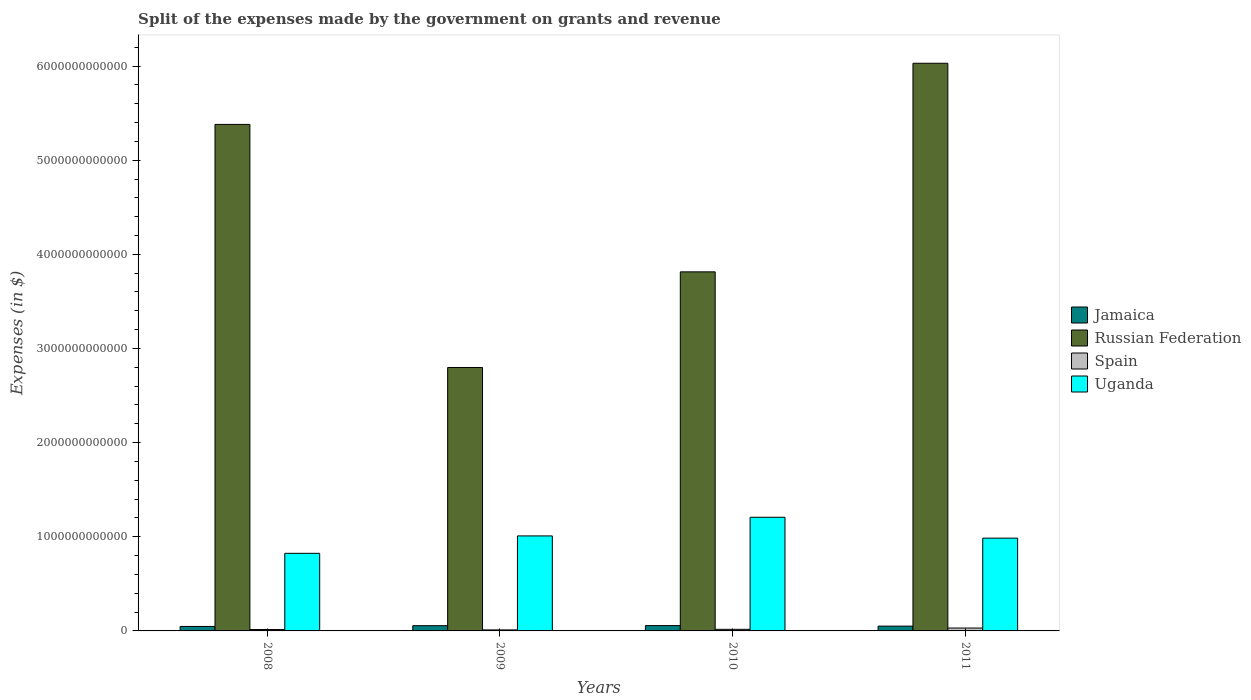How many groups of bars are there?
Your response must be concise. 4. Are the number of bars on each tick of the X-axis equal?
Your answer should be compact. Yes. How many bars are there on the 4th tick from the left?
Offer a very short reply. 4. How many bars are there on the 4th tick from the right?
Make the answer very short. 4. What is the expenses made by the government on grants and revenue in Spain in 2010?
Your response must be concise. 1.70e+1. Across all years, what is the maximum expenses made by the government on grants and revenue in Russian Federation?
Your answer should be very brief. 6.03e+12. Across all years, what is the minimum expenses made by the government on grants and revenue in Russian Federation?
Provide a succinct answer. 2.80e+12. In which year was the expenses made by the government on grants and revenue in Uganda minimum?
Offer a terse response. 2008. What is the total expenses made by the government on grants and revenue in Russian Federation in the graph?
Offer a terse response. 1.80e+13. What is the difference between the expenses made by the government on grants and revenue in Russian Federation in 2008 and that in 2010?
Offer a very short reply. 1.57e+12. What is the difference between the expenses made by the government on grants and revenue in Spain in 2008 and the expenses made by the government on grants and revenue in Jamaica in 2011?
Offer a terse response. -3.61e+1. What is the average expenses made by the government on grants and revenue in Jamaica per year?
Offer a terse response. 5.27e+1. In the year 2009, what is the difference between the expenses made by the government on grants and revenue in Spain and expenses made by the government on grants and revenue in Russian Federation?
Give a very brief answer. -2.79e+12. What is the ratio of the expenses made by the government on grants and revenue in Uganda in 2009 to that in 2010?
Provide a short and direct response. 0.84. Is the difference between the expenses made by the government on grants and revenue in Spain in 2008 and 2009 greater than the difference between the expenses made by the government on grants and revenue in Russian Federation in 2008 and 2009?
Your answer should be compact. No. What is the difference between the highest and the second highest expenses made by the government on grants and revenue in Uganda?
Your answer should be compact. 1.98e+11. What is the difference between the highest and the lowest expenses made by the government on grants and revenue in Spain?
Offer a terse response. 2.00e+1. In how many years, is the expenses made by the government on grants and revenue in Jamaica greater than the average expenses made by the government on grants and revenue in Jamaica taken over all years?
Give a very brief answer. 2. Is it the case that in every year, the sum of the expenses made by the government on grants and revenue in Uganda and expenses made by the government on grants and revenue in Russian Federation is greater than the sum of expenses made by the government on grants and revenue in Jamaica and expenses made by the government on grants and revenue in Spain?
Give a very brief answer. No. What does the 1st bar from the left in 2008 represents?
Your answer should be compact. Jamaica. What does the 1st bar from the right in 2009 represents?
Offer a very short reply. Uganda. How many bars are there?
Provide a succinct answer. 16. What is the difference between two consecutive major ticks on the Y-axis?
Your answer should be compact. 1.00e+12. Does the graph contain any zero values?
Offer a very short reply. No. Does the graph contain grids?
Keep it short and to the point. No. How many legend labels are there?
Your answer should be compact. 4. What is the title of the graph?
Give a very brief answer. Split of the expenses made by the government on grants and revenue. What is the label or title of the Y-axis?
Ensure brevity in your answer.  Expenses (in $). What is the Expenses (in $) in Jamaica in 2008?
Offer a very short reply. 4.75e+1. What is the Expenses (in $) of Russian Federation in 2008?
Give a very brief answer. 5.38e+12. What is the Expenses (in $) of Spain in 2008?
Ensure brevity in your answer.  1.49e+1. What is the Expenses (in $) of Uganda in 2008?
Provide a short and direct response. 8.24e+11. What is the Expenses (in $) in Jamaica in 2009?
Offer a very short reply. 5.55e+1. What is the Expenses (in $) in Russian Federation in 2009?
Offer a very short reply. 2.80e+12. What is the Expenses (in $) in Spain in 2009?
Keep it short and to the point. 1.08e+1. What is the Expenses (in $) of Uganda in 2009?
Ensure brevity in your answer.  1.01e+12. What is the Expenses (in $) in Jamaica in 2010?
Provide a short and direct response. 5.67e+1. What is the Expenses (in $) of Russian Federation in 2010?
Offer a very short reply. 3.81e+12. What is the Expenses (in $) in Spain in 2010?
Make the answer very short. 1.70e+1. What is the Expenses (in $) of Uganda in 2010?
Your response must be concise. 1.21e+12. What is the Expenses (in $) of Jamaica in 2011?
Provide a short and direct response. 5.10e+1. What is the Expenses (in $) in Russian Federation in 2011?
Ensure brevity in your answer.  6.03e+12. What is the Expenses (in $) in Spain in 2011?
Offer a very short reply. 3.08e+1. What is the Expenses (in $) in Uganda in 2011?
Give a very brief answer. 9.86e+11. Across all years, what is the maximum Expenses (in $) in Jamaica?
Provide a short and direct response. 5.67e+1. Across all years, what is the maximum Expenses (in $) in Russian Federation?
Ensure brevity in your answer.  6.03e+12. Across all years, what is the maximum Expenses (in $) in Spain?
Offer a very short reply. 3.08e+1. Across all years, what is the maximum Expenses (in $) of Uganda?
Give a very brief answer. 1.21e+12. Across all years, what is the minimum Expenses (in $) of Jamaica?
Make the answer very short. 4.75e+1. Across all years, what is the minimum Expenses (in $) in Russian Federation?
Give a very brief answer. 2.80e+12. Across all years, what is the minimum Expenses (in $) of Spain?
Your answer should be very brief. 1.08e+1. Across all years, what is the minimum Expenses (in $) of Uganda?
Provide a short and direct response. 8.24e+11. What is the total Expenses (in $) of Jamaica in the graph?
Your answer should be compact. 2.11e+11. What is the total Expenses (in $) of Russian Federation in the graph?
Make the answer very short. 1.80e+13. What is the total Expenses (in $) in Spain in the graph?
Offer a terse response. 7.35e+1. What is the total Expenses (in $) of Uganda in the graph?
Give a very brief answer. 4.03e+12. What is the difference between the Expenses (in $) of Jamaica in 2008 and that in 2009?
Your response must be concise. -8.07e+09. What is the difference between the Expenses (in $) of Russian Federation in 2008 and that in 2009?
Provide a short and direct response. 2.58e+12. What is the difference between the Expenses (in $) of Spain in 2008 and that in 2009?
Your answer should be very brief. 4.06e+09. What is the difference between the Expenses (in $) in Uganda in 2008 and that in 2009?
Give a very brief answer. -1.85e+11. What is the difference between the Expenses (in $) of Jamaica in 2008 and that in 2010?
Your answer should be compact. -9.24e+09. What is the difference between the Expenses (in $) in Russian Federation in 2008 and that in 2010?
Your response must be concise. 1.57e+12. What is the difference between the Expenses (in $) of Spain in 2008 and that in 2010?
Offer a terse response. -2.12e+09. What is the difference between the Expenses (in $) of Uganda in 2008 and that in 2010?
Provide a succinct answer. -3.83e+11. What is the difference between the Expenses (in $) in Jamaica in 2008 and that in 2011?
Your response must be concise. -3.50e+09. What is the difference between the Expenses (in $) in Russian Federation in 2008 and that in 2011?
Offer a very short reply. -6.49e+11. What is the difference between the Expenses (in $) in Spain in 2008 and that in 2011?
Your answer should be compact. -1.60e+1. What is the difference between the Expenses (in $) of Uganda in 2008 and that in 2011?
Provide a succinct answer. -1.61e+11. What is the difference between the Expenses (in $) in Jamaica in 2009 and that in 2010?
Your answer should be compact. -1.17e+09. What is the difference between the Expenses (in $) in Russian Federation in 2009 and that in 2010?
Keep it short and to the point. -1.02e+12. What is the difference between the Expenses (in $) of Spain in 2009 and that in 2010?
Ensure brevity in your answer.  -6.18e+09. What is the difference between the Expenses (in $) of Uganda in 2009 and that in 2010?
Your answer should be compact. -1.98e+11. What is the difference between the Expenses (in $) in Jamaica in 2009 and that in 2011?
Give a very brief answer. 4.57e+09. What is the difference between the Expenses (in $) in Russian Federation in 2009 and that in 2011?
Make the answer very short. -3.23e+12. What is the difference between the Expenses (in $) in Spain in 2009 and that in 2011?
Keep it short and to the point. -2.00e+1. What is the difference between the Expenses (in $) of Uganda in 2009 and that in 2011?
Offer a very short reply. 2.35e+1. What is the difference between the Expenses (in $) of Jamaica in 2010 and that in 2011?
Provide a short and direct response. 5.74e+09. What is the difference between the Expenses (in $) of Russian Federation in 2010 and that in 2011?
Ensure brevity in your answer.  -2.22e+12. What is the difference between the Expenses (in $) in Spain in 2010 and that in 2011?
Offer a terse response. -1.39e+1. What is the difference between the Expenses (in $) of Uganda in 2010 and that in 2011?
Keep it short and to the point. 2.22e+11. What is the difference between the Expenses (in $) of Jamaica in 2008 and the Expenses (in $) of Russian Federation in 2009?
Offer a terse response. -2.75e+12. What is the difference between the Expenses (in $) in Jamaica in 2008 and the Expenses (in $) in Spain in 2009?
Make the answer very short. 3.67e+1. What is the difference between the Expenses (in $) in Jamaica in 2008 and the Expenses (in $) in Uganda in 2009?
Provide a succinct answer. -9.62e+11. What is the difference between the Expenses (in $) of Russian Federation in 2008 and the Expenses (in $) of Spain in 2009?
Offer a very short reply. 5.37e+12. What is the difference between the Expenses (in $) in Russian Federation in 2008 and the Expenses (in $) in Uganda in 2009?
Your response must be concise. 4.37e+12. What is the difference between the Expenses (in $) of Spain in 2008 and the Expenses (in $) of Uganda in 2009?
Your answer should be compact. -9.94e+11. What is the difference between the Expenses (in $) of Jamaica in 2008 and the Expenses (in $) of Russian Federation in 2010?
Provide a short and direct response. -3.77e+12. What is the difference between the Expenses (in $) in Jamaica in 2008 and the Expenses (in $) in Spain in 2010?
Your answer should be very brief. 3.05e+1. What is the difference between the Expenses (in $) in Jamaica in 2008 and the Expenses (in $) in Uganda in 2010?
Your answer should be very brief. -1.16e+12. What is the difference between the Expenses (in $) in Russian Federation in 2008 and the Expenses (in $) in Spain in 2010?
Your response must be concise. 5.36e+12. What is the difference between the Expenses (in $) in Russian Federation in 2008 and the Expenses (in $) in Uganda in 2010?
Make the answer very short. 4.17e+12. What is the difference between the Expenses (in $) of Spain in 2008 and the Expenses (in $) of Uganda in 2010?
Offer a very short reply. -1.19e+12. What is the difference between the Expenses (in $) of Jamaica in 2008 and the Expenses (in $) of Russian Federation in 2011?
Your response must be concise. -5.98e+12. What is the difference between the Expenses (in $) in Jamaica in 2008 and the Expenses (in $) in Spain in 2011?
Give a very brief answer. 1.66e+1. What is the difference between the Expenses (in $) of Jamaica in 2008 and the Expenses (in $) of Uganda in 2011?
Offer a terse response. -9.38e+11. What is the difference between the Expenses (in $) of Russian Federation in 2008 and the Expenses (in $) of Spain in 2011?
Your response must be concise. 5.35e+12. What is the difference between the Expenses (in $) in Russian Federation in 2008 and the Expenses (in $) in Uganda in 2011?
Ensure brevity in your answer.  4.39e+12. What is the difference between the Expenses (in $) in Spain in 2008 and the Expenses (in $) in Uganda in 2011?
Your response must be concise. -9.71e+11. What is the difference between the Expenses (in $) in Jamaica in 2009 and the Expenses (in $) in Russian Federation in 2010?
Provide a succinct answer. -3.76e+12. What is the difference between the Expenses (in $) of Jamaica in 2009 and the Expenses (in $) of Spain in 2010?
Make the answer very short. 3.85e+1. What is the difference between the Expenses (in $) of Jamaica in 2009 and the Expenses (in $) of Uganda in 2010?
Your response must be concise. -1.15e+12. What is the difference between the Expenses (in $) in Russian Federation in 2009 and the Expenses (in $) in Spain in 2010?
Provide a succinct answer. 2.78e+12. What is the difference between the Expenses (in $) of Russian Federation in 2009 and the Expenses (in $) of Uganda in 2010?
Your response must be concise. 1.59e+12. What is the difference between the Expenses (in $) in Spain in 2009 and the Expenses (in $) in Uganda in 2010?
Give a very brief answer. -1.20e+12. What is the difference between the Expenses (in $) in Jamaica in 2009 and the Expenses (in $) in Russian Federation in 2011?
Your answer should be compact. -5.97e+12. What is the difference between the Expenses (in $) of Jamaica in 2009 and the Expenses (in $) of Spain in 2011?
Your answer should be compact. 2.47e+1. What is the difference between the Expenses (in $) of Jamaica in 2009 and the Expenses (in $) of Uganda in 2011?
Your answer should be compact. -9.30e+11. What is the difference between the Expenses (in $) of Russian Federation in 2009 and the Expenses (in $) of Spain in 2011?
Your answer should be very brief. 2.77e+12. What is the difference between the Expenses (in $) of Russian Federation in 2009 and the Expenses (in $) of Uganda in 2011?
Provide a succinct answer. 1.81e+12. What is the difference between the Expenses (in $) of Spain in 2009 and the Expenses (in $) of Uganda in 2011?
Keep it short and to the point. -9.75e+11. What is the difference between the Expenses (in $) in Jamaica in 2010 and the Expenses (in $) in Russian Federation in 2011?
Provide a succinct answer. -5.97e+12. What is the difference between the Expenses (in $) of Jamaica in 2010 and the Expenses (in $) of Spain in 2011?
Provide a succinct answer. 2.59e+1. What is the difference between the Expenses (in $) of Jamaica in 2010 and the Expenses (in $) of Uganda in 2011?
Give a very brief answer. -9.29e+11. What is the difference between the Expenses (in $) in Russian Federation in 2010 and the Expenses (in $) in Spain in 2011?
Your answer should be very brief. 3.78e+12. What is the difference between the Expenses (in $) in Russian Federation in 2010 and the Expenses (in $) in Uganda in 2011?
Your answer should be very brief. 2.83e+12. What is the difference between the Expenses (in $) in Spain in 2010 and the Expenses (in $) in Uganda in 2011?
Make the answer very short. -9.69e+11. What is the average Expenses (in $) of Jamaica per year?
Your response must be concise. 5.27e+1. What is the average Expenses (in $) of Russian Federation per year?
Offer a terse response. 4.51e+12. What is the average Expenses (in $) of Spain per year?
Provide a succinct answer. 1.84e+1. What is the average Expenses (in $) of Uganda per year?
Keep it short and to the point. 1.01e+12. In the year 2008, what is the difference between the Expenses (in $) in Jamaica and Expenses (in $) in Russian Federation?
Your answer should be very brief. -5.33e+12. In the year 2008, what is the difference between the Expenses (in $) in Jamaica and Expenses (in $) in Spain?
Your response must be concise. 3.26e+1. In the year 2008, what is the difference between the Expenses (in $) in Jamaica and Expenses (in $) in Uganda?
Your response must be concise. -7.77e+11. In the year 2008, what is the difference between the Expenses (in $) in Russian Federation and Expenses (in $) in Spain?
Ensure brevity in your answer.  5.37e+12. In the year 2008, what is the difference between the Expenses (in $) in Russian Federation and Expenses (in $) in Uganda?
Give a very brief answer. 4.56e+12. In the year 2008, what is the difference between the Expenses (in $) of Spain and Expenses (in $) of Uganda?
Make the answer very short. -8.09e+11. In the year 2009, what is the difference between the Expenses (in $) of Jamaica and Expenses (in $) of Russian Federation?
Your answer should be compact. -2.74e+12. In the year 2009, what is the difference between the Expenses (in $) in Jamaica and Expenses (in $) in Spain?
Provide a short and direct response. 4.47e+1. In the year 2009, what is the difference between the Expenses (in $) in Jamaica and Expenses (in $) in Uganda?
Offer a terse response. -9.54e+11. In the year 2009, what is the difference between the Expenses (in $) in Russian Federation and Expenses (in $) in Spain?
Your response must be concise. 2.79e+12. In the year 2009, what is the difference between the Expenses (in $) in Russian Federation and Expenses (in $) in Uganda?
Offer a terse response. 1.79e+12. In the year 2009, what is the difference between the Expenses (in $) of Spain and Expenses (in $) of Uganda?
Provide a succinct answer. -9.98e+11. In the year 2010, what is the difference between the Expenses (in $) of Jamaica and Expenses (in $) of Russian Federation?
Offer a terse response. -3.76e+12. In the year 2010, what is the difference between the Expenses (in $) of Jamaica and Expenses (in $) of Spain?
Make the answer very short. 3.97e+1. In the year 2010, what is the difference between the Expenses (in $) of Jamaica and Expenses (in $) of Uganda?
Your response must be concise. -1.15e+12. In the year 2010, what is the difference between the Expenses (in $) in Russian Federation and Expenses (in $) in Spain?
Ensure brevity in your answer.  3.80e+12. In the year 2010, what is the difference between the Expenses (in $) of Russian Federation and Expenses (in $) of Uganda?
Your response must be concise. 2.61e+12. In the year 2010, what is the difference between the Expenses (in $) in Spain and Expenses (in $) in Uganda?
Your response must be concise. -1.19e+12. In the year 2011, what is the difference between the Expenses (in $) in Jamaica and Expenses (in $) in Russian Federation?
Offer a very short reply. -5.98e+12. In the year 2011, what is the difference between the Expenses (in $) in Jamaica and Expenses (in $) in Spain?
Give a very brief answer. 2.01e+1. In the year 2011, what is the difference between the Expenses (in $) of Jamaica and Expenses (in $) of Uganda?
Ensure brevity in your answer.  -9.35e+11. In the year 2011, what is the difference between the Expenses (in $) of Russian Federation and Expenses (in $) of Spain?
Your answer should be very brief. 6.00e+12. In the year 2011, what is the difference between the Expenses (in $) in Russian Federation and Expenses (in $) in Uganda?
Offer a terse response. 5.04e+12. In the year 2011, what is the difference between the Expenses (in $) in Spain and Expenses (in $) in Uganda?
Offer a very short reply. -9.55e+11. What is the ratio of the Expenses (in $) in Jamaica in 2008 to that in 2009?
Ensure brevity in your answer.  0.85. What is the ratio of the Expenses (in $) of Russian Federation in 2008 to that in 2009?
Your answer should be very brief. 1.92. What is the ratio of the Expenses (in $) of Spain in 2008 to that in 2009?
Provide a short and direct response. 1.38. What is the ratio of the Expenses (in $) of Uganda in 2008 to that in 2009?
Give a very brief answer. 0.82. What is the ratio of the Expenses (in $) in Jamaica in 2008 to that in 2010?
Your response must be concise. 0.84. What is the ratio of the Expenses (in $) in Russian Federation in 2008 to that in 2010?
Keep it short and to the point. 1.41. What is the ratio of the Expenses (in $) of Spain in 2008 to that in 2010?
Give a very brief answer. 0.87. What is the ratio of the Expenses (in $) of Uganda in 2008 to that in 2010?
Provide a succinct answer. 0.68. What is the ratio of the Expenses (in $) of Jamaica in 2008 to that in 2011?
Make the answer very short. 0.93. What is the ratio of the Expenses (in $) in Russian Federation in 2008 to that in 2011?
Offer a very short reply. 0.89. What is the ratio of the Expenses (in $) in Spain in 2008 to that in 2011?
Your response must be concise. 0.48. What is the ratio of the Expenses (in $) of Uganda in 2008 to that in 2011?
Provide a short and direct response. 0.84. What is the ratio of the Expenses (in $) of Jamaica in 2009 to that in 2010?
Keep it short and to the point. 0.98. What is the ratio of the Expenses (in $) in Russian Federation in 2009 to that in 2010?
Make the answer very short. 0.73. What is the ratio of the Expenses (in $) in Spain in 2009 to that in 2010?
Offer a terse response. 0.64. What is the ratio of the Expenses (in $) of Uganda in 2009 to that in 2010?
Your answer should be very brief. 0.84. What is the ratio of the Expenses (in $) of Jamaica in 2009 to that in 2011?
Your answer should be very brief. 1.09. What is the ratio of the Expenses (in $) of Russian Federation in 2009 to that in 2011?
Your answer should be very brief. 0.46. What is the ratio of the Expenses (in $) in Spain in 2009 to that in 2011?
Offer a very short reply. 0.35. What is the ratio of the Expenses (in $) of Uganda in 2009 to that in 2011?
Give a very brief answer. 1.02. What is the ratio of the Expenses (in $) of Jamaica in 2010 to that in 2011?
Your answer should be compact. 1.11. What is the ratio of the Expenses (in $) in Russian Federation in 2010 to that in 2011?
Offer a terse response. 0.63. What is the ratio of the Expenses (in $) in Spain in 2010 to that in 2011?
Your response must be concise. 0.55. What is the ratio of the Expenses (in $) of Uganda in 2010 to that in 2011?
Your answer should be compact. 1.22. What is the difference between the highest and the second highest Expenses (in $) of Jamaica?
Your answer should be compact. 1.17e+09. What is the difference between the highest and the second highest Expenses (in $) in Russian Federation?
Offer a very short reply. 6.49e+11. What is the difference between the highest and the second highest Expenses (in $) of Spain?
Offer a very short reply. 1.39e+1. What is the difference between the highest and the second highest Expenses (in $) of Uganda?
Provide a succinct answer. 1.98e+11. What is the difference between the highest and the lowest Expenses (in $) of Jamaica?
Your answer should be compact. 9.24e+09. What is the difference between the highest and the lowest Expenses (in $) of Russian Federation?
Keep it short and to the point. 3.23e+12. What is the difference between the highest and the lowest Expenses (in $) in Spain?
Keep it short and to the point. 2.00e+1. What is the difference between the highest and the lowest Expenses (in $) in Uganda?
Give a very brief answer. 3.83e+11. 